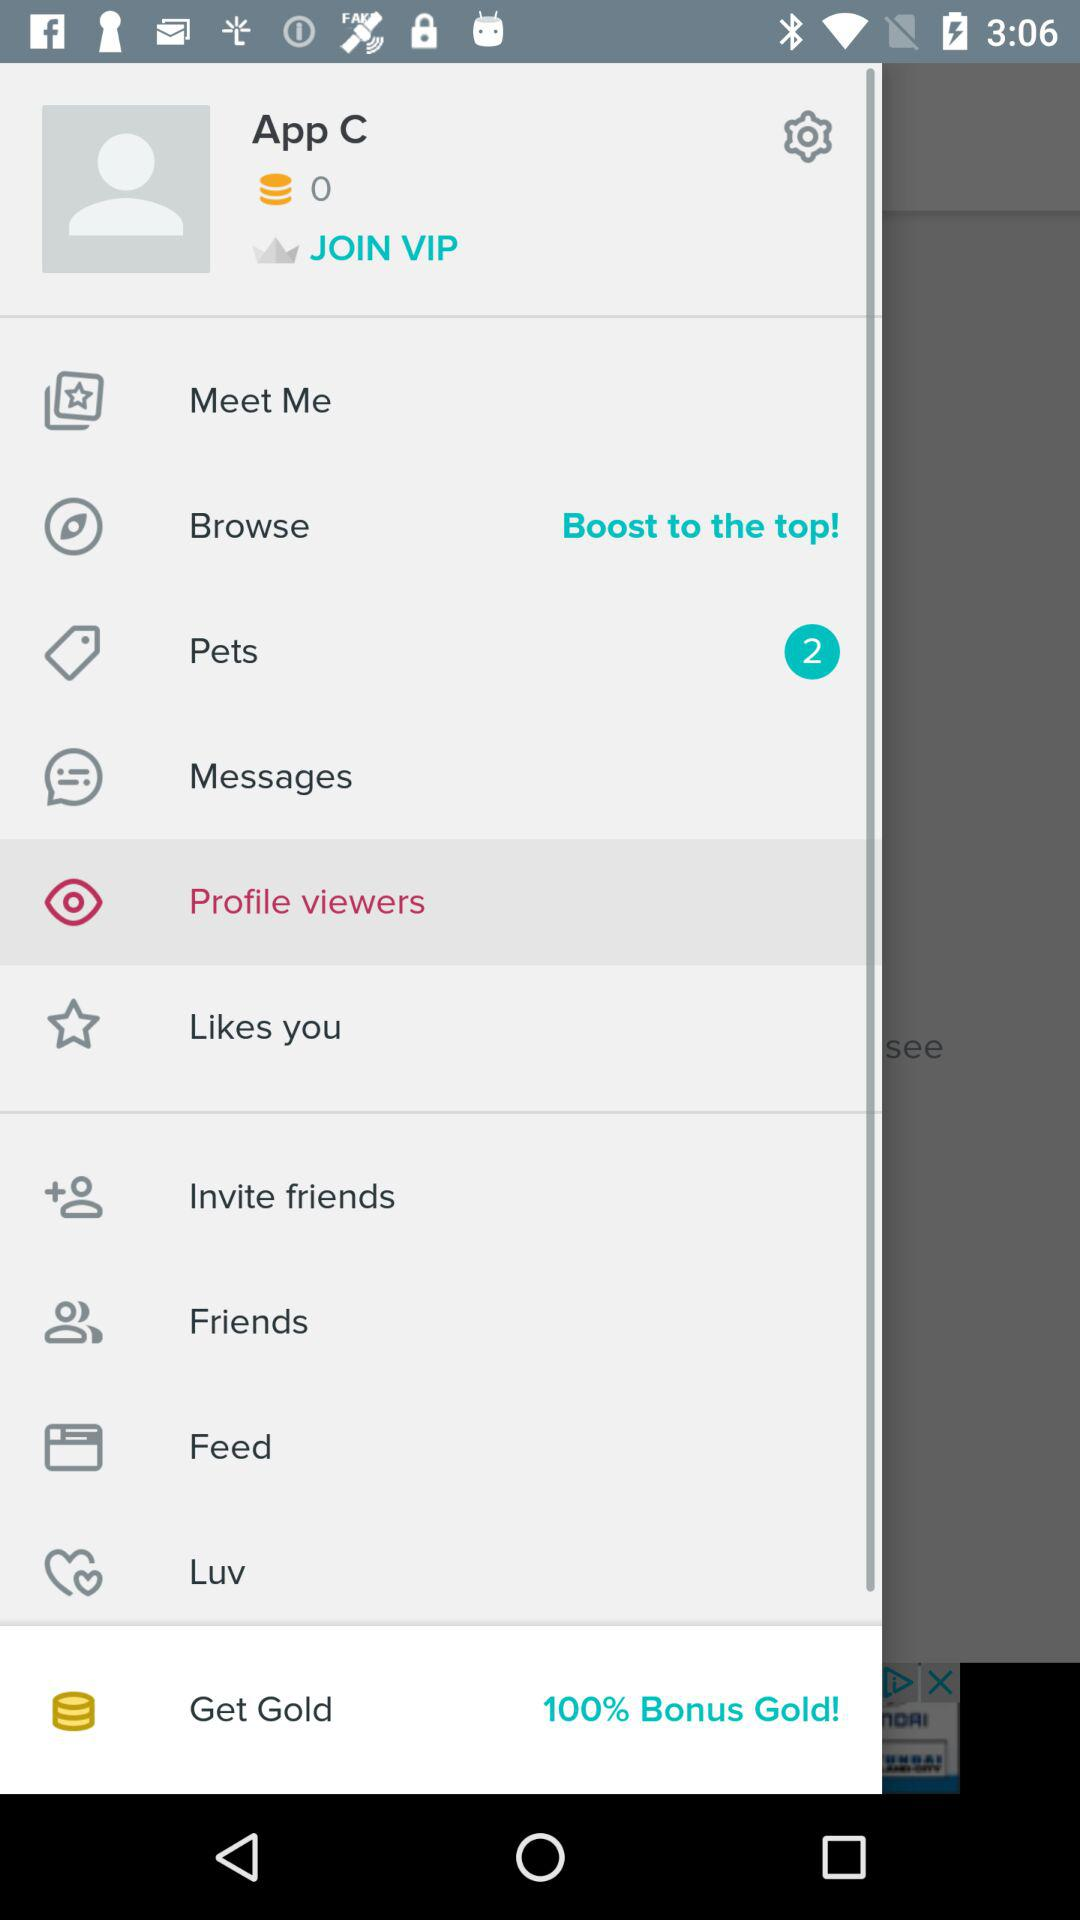Which is the selected item in the menu? The selected item is "Profile viewers". 